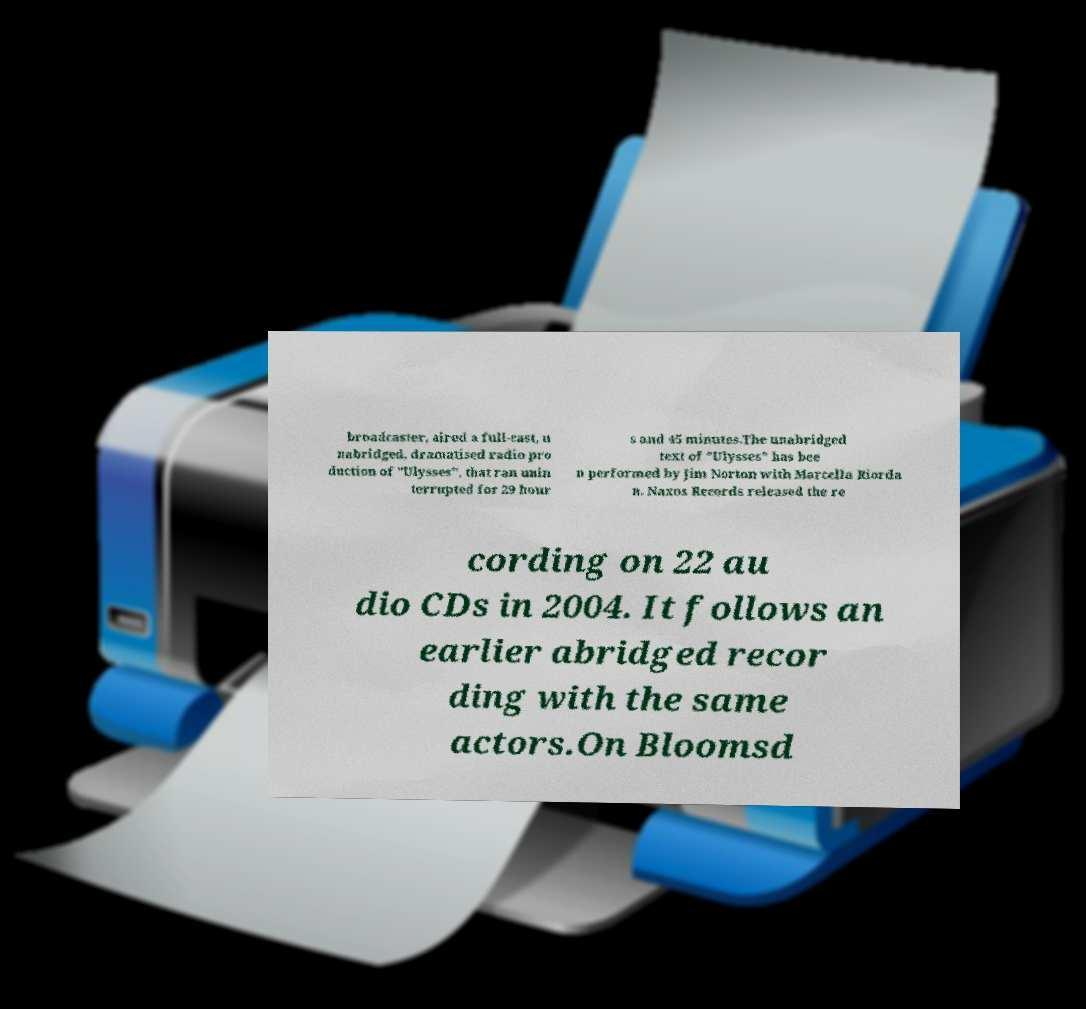Please read and relay the text visible in this image. What does it say? broadcaster, aired a full-cast, u nabridged, dramatised radio pro duction of "Ulysses", that ran unin terrupted for 29 hour s and 45 minutes.The unabridged text of "Ulysses" has bee n performed by Jim Norton with Marcella Riorda n. Naxos Records released the re cording on 22 au dio CDs in 2004. It follows an earlier abridged recor ding with the same actors.On Bloomsd 